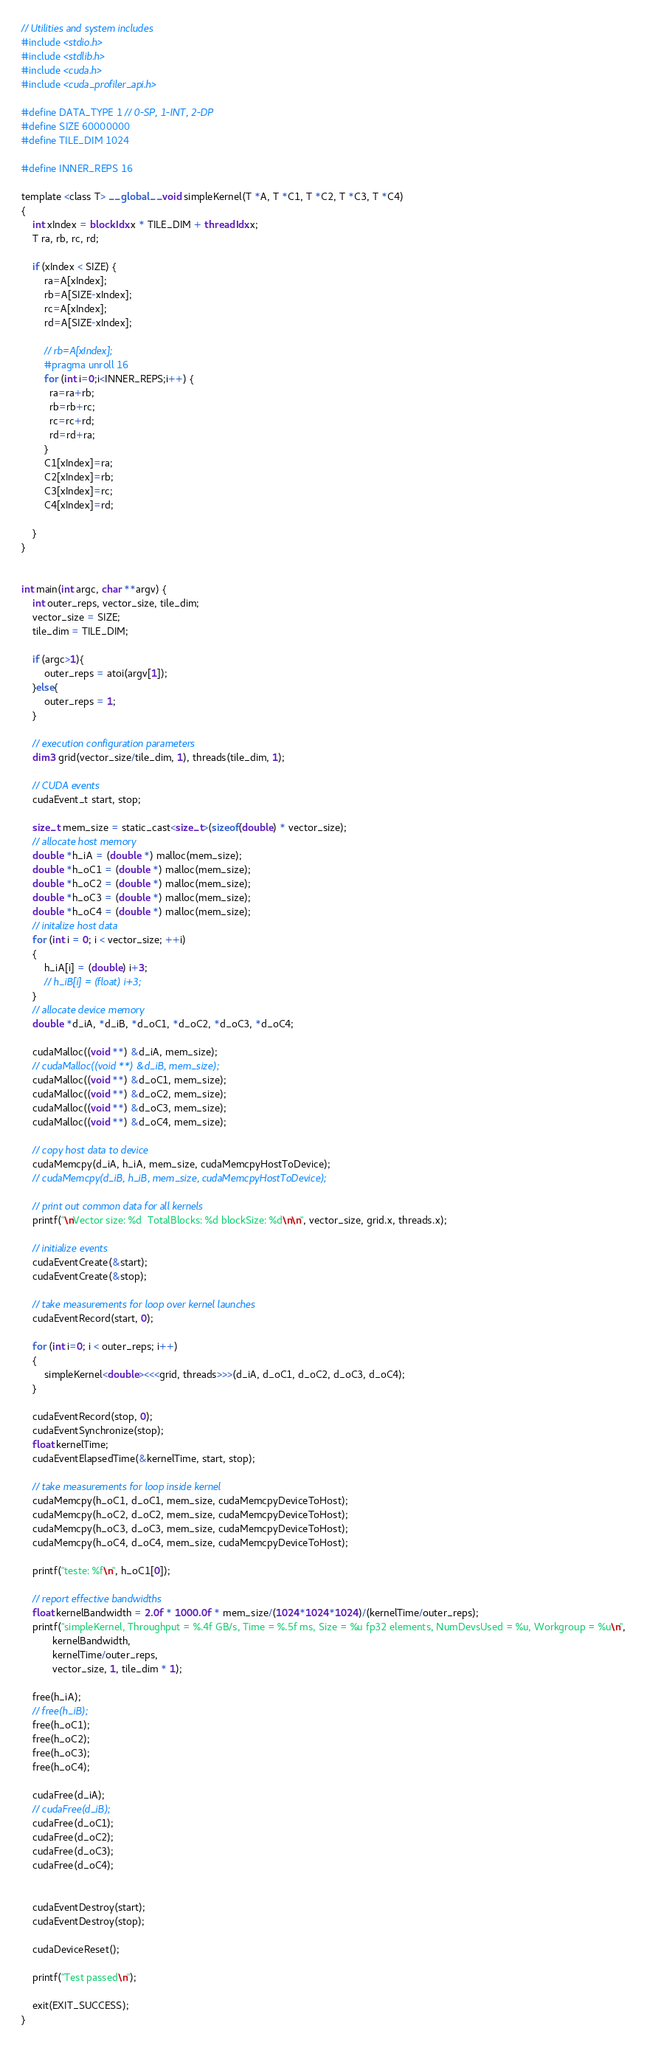Convert code to text. <code><loc_0><loc_0><loc_500><loc_500><_Cuda_>// Utilities and system includes
#include <stdio.h>
#include <stdlib.h>
#include <cuda.h>
#include <cuda_profiler_api.h>

#define DATA_TYPE 1 // 0-SP, 1-INT, 2-DP
#define SIZE 60000000
#define TILE_DIM 1024

#define INNER_REPS 16

template <class T> __global__ void simpleKernel(T *A, T *C1, T *C2, T *C3, T *C4)
{
    int xIndex = blockIdx.x * TILE_DIM + threadIdx.x;
    T ra, rb, rc, rd;

    if (xIndex < SIZE) {
        ra=A[xIndex];
        rb=A[SIZE-xIndex];
        rc=A[xIndex];
        rd=A[SIZE-xIndex];

        // rb=A[xIndex];
        #pragma unroll 16
        for (int i=0;i<INNER_REPS;i++) {
          ra=ra+rb;
          rb=rb+rc;
          rc=rc+rd;
          rd=rd+ra;
        }
        C1[xIndex]=ra;
        C2[xIndex]=rb;
        C3[xIndex]=rc;
        C4[xIndex]=rd;

    }
}


int main(int argc, char **argv) {
    int outer_reps, vector_size, tile_dim;
    vector_size = SIZE;
    tile_dim = TILE_DIM;

    if (argc>1){
        outer_reps = atoi(argv[1]);
    }else{
        outer_reps = 1;
    }

    // execution configuration parameters
    dim3 grid(vector_size/tile_dim, 1), threads(tile_dim, 1);

    // CUDA events
    cudaEvent_t start, stop;

    size_t mem_size = static_cast<size_t>(sizeof(double) * vector_size);
    // allocate host memory
    double *h_iA = (double *) malloc(mem_size);
    double *h_oC1 = (double *) malloc(mem_size);
    double *h_oC2 = (double *) malloc(mem_size);
    double *h_oC3 = (double *) malloc(mem_size);
    double *h_oC4 = (double *) malloc(mem_size);
    // initalize host data
    for (int i = 0; i < vector_size; ++i)
    {
        h_iA[i] = (double) i+3;
        // h_iB[i] = (float) i+3;
    }
    // allocate device memory
    double *d_iA, *d_iB, *d_oC1, *d_oC2, *d_oC3, *d_oC4;

    cudaMalloc((void **) &d_iA, mem_size);
    // cudaMalloc((void **) &d_iB, mem_size);
    cudaMalloc((void **) &d_oC1, mem_size);
    cudaMalloc((void **) &d_oC2, mem_size);
    cudaMalloc((void **) &d_oC3, mem_size);
    cudaMalloc((void **) &d_oC4, mem_size);

    // copy host data to device
    cudaMemcpy(d_iA, h_iA, mem_size, cudaMemcpyHostToDevice);
    // cudaMemcpy(d_iB, h_iB, mem_size, cudaMemcpyHostToDevice);

    // print out common data for all kernels
    printf("\nVector size: %d  TotalBlocks: %d blockSize: %d\n\n", vector_size, grid.x, threads.x);

    // initialize events
    cudaEventCreate(&start);
    cudaEventCreate(&stop);

    // take measurements for loop over kernel launches
    cudaEventRecord(start, 0);

    for (int i=0; i < outer_reps; i++)
    {
        simpleKernel<double><<<grid, threads>>>(d_iA, d_oC1, d_oC2, d_oC3, d_oC4);
    }

    cudaEventRecord(stop, 0);
    cudaEventSynchronize(stop);
    float kernelTime;
    cudaEventElapsedTime(&kernelTime, start, stop);

    // take measurements for loop inside kernel
    cudaMemcpy(h_oC1, d_oC1, mem_size, cudaMemcpyDeviceToHost);
    cudaMemcpy(h_oC2, d_oC2, mem_size, cudaMemcpyDeviceToHost);
    cudaMemcpy(h_oC3, d_oC3, mem_size, cudaMemcpyDeviceToHost);
    cudaMemcpy(h_oC4, d_oC4, mem_size, cudaMemcpyDeviceToHost);

    printf("teste: %f\n", h_oC1[0]);

    // report effective bandwidths
    float kernelBandwidth = 2.0f * 1000.0f * mem_size/(1024*1024*1024)/(kernelTime/outer_reps);
    printf("simpleKernel, Throughput = %.4f GB/s, Time = %.5f ms, Size = %u fp32 elements, NumDevsUsed = %u, Workgroup = %u\n",
           kernelBandwidth,
           kernelTime/outer_reps,
           vector_size, 1, tile_dim * 1);

    free(h_iA);
    // free(h_iB);
    free(h_oC1);
    free(h_oC2);
    free(h_oC3);
    free(h_oC4);

    cudaFree(d_iA);
    // cudaFree(d_iB);
    cudaFree(d_oC1);
    cudaFree(d_oC2);
    cudaFree(d_oC3);
    cudaFree(d_oC4);


    cudaEventDestroy(start);
    cudaEventDestroy(stop);

    cudaDeviceReset();

    printf("Test passed\n");

    exit(EXIT_SUCCESS);
}
</code> 